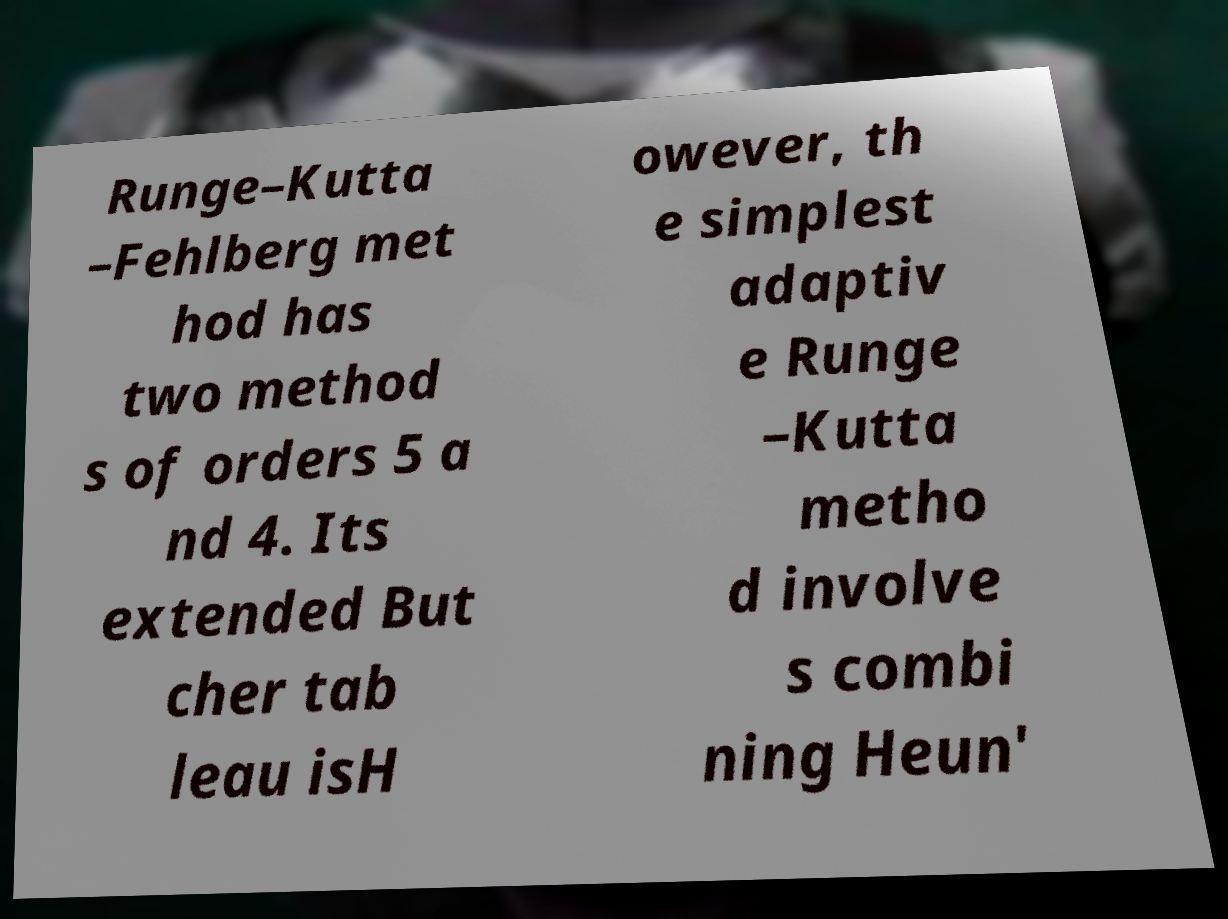I need the written content from this picture converted into text. Can you do that? Runge–Kutta –Fehlberg met hod has two method s of orders 5 a nd 4. Its extended But cher tab leau isH owever, th e simplest adaptiv e Runge –Kutta metho d involve s combi ning Heun' 